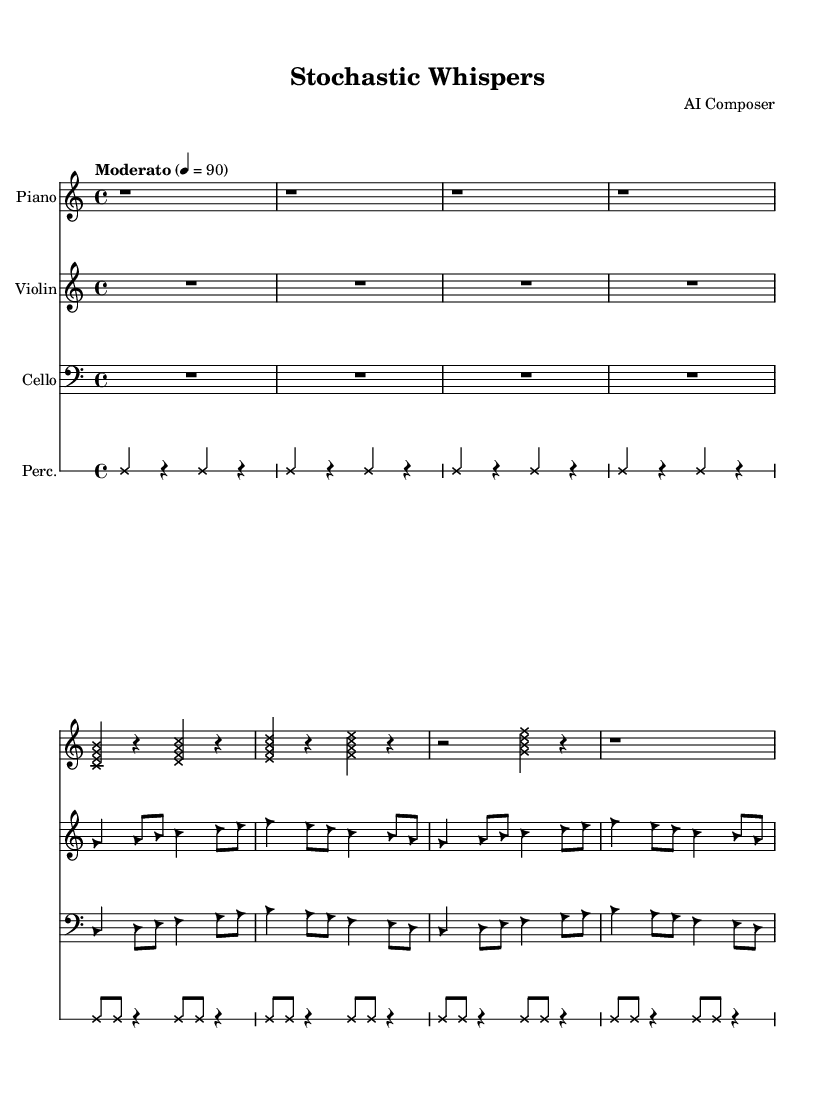What is the time signature of this music? The time signature is indicated at the beginning of the score as 4/4, which shows that there are four beats in each measure.
Answer: 4/4 What is the tempo marking for the piece? The tempo marking is indicated using the term "Moderato" followed by a metronome marking of 90, indicating a moderately paced tempo at 90 beats per minute.
Answer: Moderato 90 How many instruments are featured in this composition? By identifying each staff in the score, we can count four distinct instruments: piano, violin, cello, and percussion.
Answer: Four What is the note style used for the piano part? The note style for the piano part is specified as 'cross', which is indicated by the override setting in the corresponding staff.
Answer: Cross Which instrument plays notes with a triangular note head? The override for the note head style to 'triangle' is set for both the violin and cello parts, making these the two instruments that use triangular note heads.
Answer: Violin and Cello How many measures are in the percussion part? By counting the rhythm notations in the percussion staff, we observe it includes eight measures, each featuring repeated rhythmic patterns.
Answer: Eight What type of sound does the piece incorporate alongside the instruments? The composition features randomized elements and white noise, which are characteristic of avant-garde music, indicated in the description.
Answer: White noise and randomized elements 